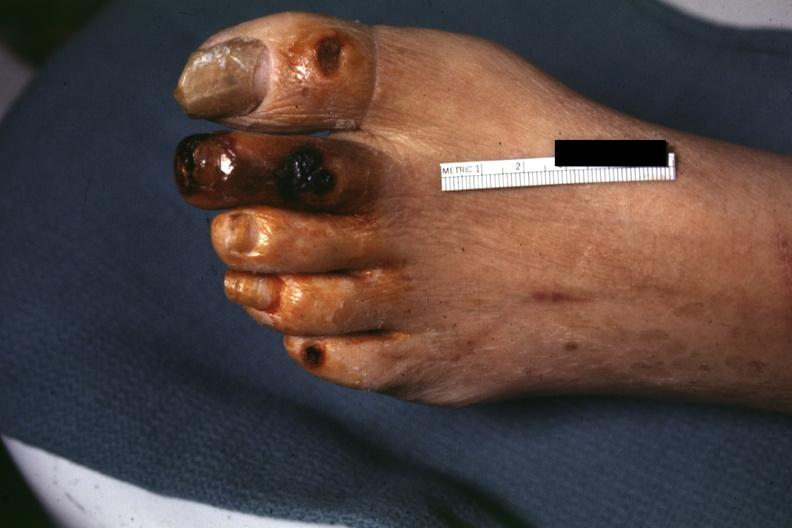what does this image show?
Answer the question using a single word or phrase. Good close-up of gangrene 